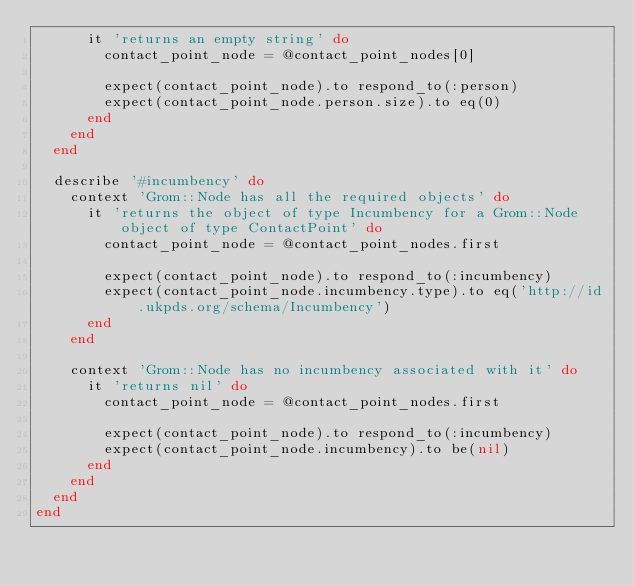<code> <loc_0><loc_0><loc_500><loc_500><_Ruby_>      it 'returns an empty string' do
        contact_point_node = @contact_point_nodes[0]

        expect(contact_point_node).to respond_to(:person)
        expect(contact_point_node.person.size).to eq(0)
      end
    end
  end

  describe '#incumbency' do
    context 'Grom::Node has all the required objects' do
      it 'returns the object of type Incumbency for a Grom::Node object of type ContactPoint' do
        contact_point_node = @contact_point_nodes.first

        expect(contact_point_node).to respond_to(:incumbency)
        expect(contact_point_node.incumbency.type).to eq('http://id.ukpds.org/schema/Incumbency')
      end
    end

    context 'Grom::Node has no incumbency associated with it' do
      it 'returns nil' do
        contact_point_node = @contact_point_nodes.first

        expect(contact_point_node).to respond_to(:incumbency)
        expect(contact_point_node.incumbency).to be(nil)
      end
    end
  end
end
</code> 